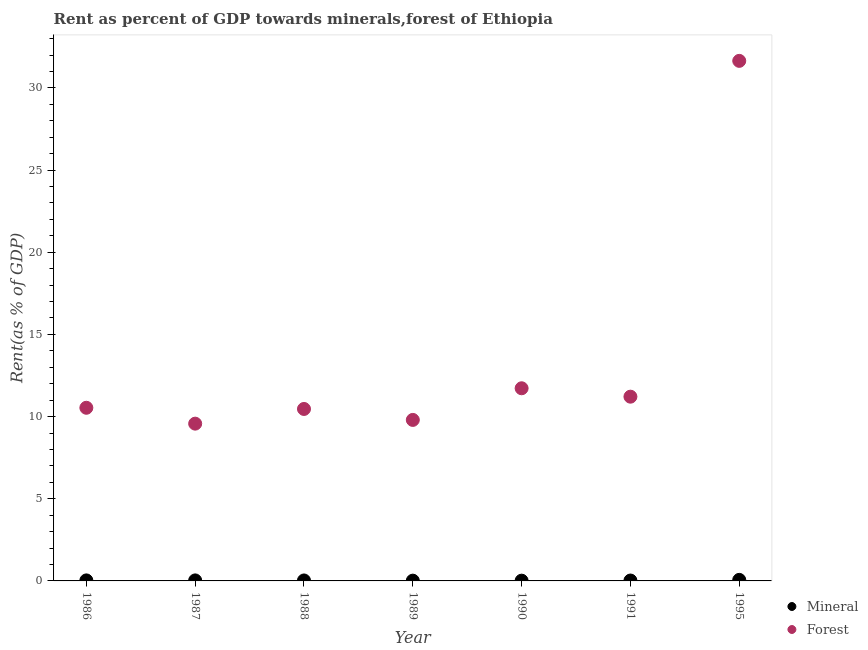How many different coloured dotlines are there?
Make the answer very short. 2. What is the mineral rent in 1987?
Ensure brevity in your answer.  0.03. Across all years, what is the maximum mineral rent?
Provide a short and direct response. 0.06. Across all years, what is the minimum forest rent?
Ensure brevity in your answer.  9.57. In which year was the mineral rent maximum?
Your answer should be compact. 1995. In which year was the forest rent minimum?
Provide a succinct answer. 1987. What is the total forest rent in the graph?
Ensure brevity in your answer.  94.94. What is the difference between the mineral rent in 1987 and that in 1991?
Provide a succinct answer. 0.01. What is the difference between the forest rent in 1990 and the mineral rent in 1995?
Provide a short and direct response. 11.66. What is the average mineral rent per year?
Your response must be concise. 0.03. In the year 1995, what is the difference between the mineral rent and forest rent?
Ensure brevity in your answer.  -31.58. In how many years, is the forest rent greater than 12 %?
Ensure brevity in your answer.  1. What is the ratio of the forest rent in 1987 to that in 1989?
Provide a short and direct response. 0.98. Is the difference between the mineral rent in 1987 and 1991 greater than the difference between the forest rent in 1987 and 1991?
Make the answer very short. Yes. What is the difference between the highest and the second highest mineral rent?
Provide a succinct answer. 0.03. What is the difference between the highest and the lowest forest rent?
Your response must be concise. 22.07. Is the sum of the mineral rent in 1987 and 1989 greater than the maximum forest rent across all years?
Offer a very short reply. No. Does the mineral rent monotonically increase over the years?
Ensure brevity in your answer.  No. Is the mineral rent strictly greater than the forest rent over the years?
Provide a short and direct response. No. How many dotlines are there?
Make the answer very short. 2. How many years are there in the graph?
Make the answer very short. 7. Are the values on the major ticks of Y-axis written in scientific E-notation?
Your answer should be compact. No. How are the legend labels stacked?
Offer a terse response. Vertical. What is the title of the graph?
Keep it short and to the point. Rent as percent of GDP towards minerals,forest of Ethiopia. What is the label or title of the X-axis?
Give a very brief answer. Year. What is the label or title of the Y-axis?
Keep it short and to the point. Rent(as % of GDP). What is the Rent(as % of GDP) of Mineral in 1986?
Provide a succinct answer. 0.03. What is the Rent(as % of GDP) of Forest in 1986?
Your response must be concise. 10.54. What is the Rent(as % of GDP) of Mineral in 1987?
Offer a very short reply. 0.03. What is the Rent(as % of GDP) in Forest in 1987?
Provide a short and direct response. 9.57. What is the Rent(as % of GDP) of Mineral in 1988?
Make the answer very short. 0.03. What is the Rent(as % of GDP) of Forest in 1988?
Your answer should be compact. 10.46. What is the Rent(as % of GDP) of Mineral in 1989?
Give a very brief answer. 0.02. What is the Rent(as % of GDP) in Forest in 1989?
Your answer should be very brief. 9.8. What is the Rent(as % of GDP) in Mineral in 1990?
Your response must be concise. 0.02. What is the Rent(as % of GDP) in Forest in 1990?
Make the answer very short. 11.72. What is the Rent(as % of GDP) of Mineral in 1991?
Offer a terse response. 0.02. What is the Rent(as % of GDP) of Forest in 1991?
Make the answer very short. 11.21. What is the Rent(as % of GDP) of Mineral in 1995?
Provide a short and direct response. 0.06. What is the Rent(as % of GDP) in Forest in 1995?
Provide a short and direct response. 31.64. Across all years, what is the maximum Rent(as % of GDP) of Mineral?
Keep it short and to the point. 0.06. Across all years, what is the maximum Rent(as % of GDP) of Forest?
Keep it short and to the point. 31.64. Across all years, what is the minimum Rent(as % of GDP) of Mineral?
Your answer should be very brief. 0.02. Across all years, what is the minimum Rent(as % of GDP) in Forest?
Keep it short and to the point. 9.57. What is the total Rent(as % of GDP) in Mineral in the graph?
Offer a terse response. 0.21. What is the total Rent(as % of GDP) in Forest in the graph?
Your answer should be compact. 94.94. What is the difference between the Rent(as % of GDP) of Mineral in 1986 and that in 1987?
Provide a short and direct response. 0. What is the difference between the Rent(as % of GDP) of Forest in 1986 and that in 1987?
Make the answer very short. 0.97. What is the difference between the Rent(as % of GDP) of Mineral in 1986 and that in 1988?
Provide a short and direct response. 0. What is the difference between the Rent(as % of GDP) in Forest in 1986 and that in 1988?
Offer a terse response. 0.07. What is the difference between the Rent(as % of GDP) of Mineral in 1986 and that in 1989?
Make the answer very short. 0.02. What is the difference between the Rent(as % of GDP) in Forest in 1986 and that in 1989?
Your answer should be very brief. 0.74. What is the difference between the Rent(as % of GDP) of Mineral in 1986 and that in 1990?
Your answer should be very brief. 0.02. What is the difference between the Rent(as % of GDP) of Forest in 1986 and that in 1990?
Your answer should be compact. -1.19. What is the difference between the Rent(as % of GDP) of Mineral in 1986 and that in 1991?
Ensure brevity in your answer.  0.01. What is the difference between the Rent(as % of GDP) of Forest in 1986 and that in 1991?
Provide a succinct answer. -0.68. What is the difference between the Rent(as % of GDP) of Mineral in 1986 and that in 1995?
Keep it short and to the point. -0.03. What is the difference between the Rent(as % of GDP) in Forest in 1986 and that in 1995?
Your answer should be compact. -21.11. What is the difference between the Rent(as % of GDP) in Mineral in 1987 and that in 1988?
Provide a short and direct response. 0. What is the difference between the Rent(as % of GDP) in Forest in 1987 and that in 1988?
Give a very brief answer. -0.89. What is the difference between the Rent(as % of GDP) of Mineral in 1987 and that in 1989?
Offer a terse response. 0.02. What is the difference between the Rent(as % of GDP) of Forest in 1987 and that in 1989?
Give a very brief answer. -0.23. What is the difference between the Rent(as % of GDP) of Mineral in 1987 and that in 1990?
Make the answer very short. 0.02. What is the difference between the Rent(as % of GDP) of Forest in 1987 and that in 1990?
Provide a succinct answer. -2.15. What is the difference between the Rent(as % of GDP) of Mineral in 1987 and that in 1991?
Make the answer very short. 0.01. What is the difference between the Rent(as % of GDP) in Forest in 1987 and that in 1991?
Your response must be concise. -1.64. What is the difference between the Rent(as % of GDP) of Mineral in 1987 and that in 1995?
Provide a succinct answer. -0.03. What is the difference between the Rent(as % of GDP) in Forest in 1987 and that in 1995?
Offer a very short reply. -22.07. What is the difference between the Rent(as % of GDP) of Mineral in 1988 and that in 1989?
Your answer should be very brief. 0.01. What is the difference between the Rent(as % of GDP) in Mineral in 1988 and that in 1990?
Keep it short and to the point. 0.01. What is the difference between the Rent(as % of GDP) in Forest in 1988 and that in 1990?
Provide a short and direct response. -1.26. What is the difference between the Rent(as % of GDP) in Mineral in 1988 and that in 1991?
Offer a terse response. 0. What is the difference between the Rent(as % of GDP) in Forest in 1988 and that in 1991?
Offer a very short reply. -0.75. What is the difference between the Rent(as % of GDP) of Mineral in 1988 and that in 1995?
Your answer should be very brief. -0.04. What is the difference between the Rent(as % of GDP) in Forest in 1988 and that in 1995?
Provide a short and direct response. -21.18. What is the difference between the Rent(as % of GDP) of Mineral in 1989 and that in 1990?
Your answer should be compact. 0. What is the difference between the Rent(as % of GDP) of Forest in 1989 and that in 1990?
Keep it short and to the point. -1.93. What is the difference between the Rent(as % of GDP) in Mineral in 1989 and that in 1991?
Your response must be concise. -0.01. What is the difference between the Rent(as % of GDP) in Forest in 1989 and that in 1991?
Give a very brief answer. -1.41. What is the difference between the Rent(as % of GDP) in Mineral in 1989 and that in 1995?
Offer a terse response. -0.05. What is the difference between the Rent(as % of GDP) of Forest in 1989 and that in 1995?
Your answer should be very brief. -21.85. What is the difference between the Rent(as % of GDP) in Mineral in 1990 and that in 1991?
Provide a succinct answer. -0.01. What is the difference between the Rent(as % of GDP) in Forest in 1990 and that in 1991?
Offer a very short reply. 0.51. What is the difference between the Rent(as % of GDP) in Mineral in 1990 and that in 1995?
Make the answer very short. -0.05. What is the difference between the Rent(as % of GDP) in Forest in 1990 and that in 1995?
Provide a short and direct response. -19.92. What is the difference between the Rent(as % of GDP) in Mineral in 1991 and that in 1995?
Your response must be concise. -0.04. What is the difference between the Rent(as % of GDP) in Forest in 1991 and that in 1995?
Your answer should be very brief. -20.43. What is the difference between the Rent(as % of GDP) in Mineral in 1986 and the Rent(as % of GDP) in Forest in 1987?
Offer a very short reply. -9.54. What is the difference between the Rent(as % of GDP) of Mineral in 1986 and the Rent(as % of GDP) of Forest in 1988?
Make the answer very short. -10.43. What is the difference between the Rent(as % of GDP) in Mineral in 1986 and the Rent(as % of GDP) in Forest in 1989?
Your answer should be compact. -9.76. What is the difference between the Rent(as % of GDP) in Mineral in 1986 and the Rent(as % of GDP) in Forest in 1990?
Your response must be concise. -11.69. What is the difference between the Rent(as % of GDP) of Mineral in 1986 and the Rent(as % of GDP) of Forest in 1991?
Keep it short and to the point. -11.18. What is the difference between the Rent(as % of GDP) in Mineral in 1986 and the Rent(as % of GDP) in Forest in 1995?
Provide a succinct answer. -31.61. What is the difference between the Rent(as % of GDP) of Mineral in 1987 and the Rent(as % of GDP) of Forest in 1988?
Offer a very short reply. -10.43. What is the difference between the Rent(as % of GDP) in Mineral in 1987 and the Rent(as % of GDP) in Forest in 1989?
Your answer should be compact. -9.77. What is the difference between the Rent(as % of GDP) of Mineral in 1987 and the Rent(as % of GDP) of Forest in 1990?
Provide a succinct answer. -11.69. What is the difference between the Rent(as % of GDP) of Mineral in 1987 and the Rent(as % of GDP) of Forest in 1991?
Ensure brevity in your answer.  -11.18. What is the difference between the Rent(as % of GDP) in Mineral in 1987 and the Rent(as % of GDP) in Forest in 1995?
Give a very brief answer. -31.61. What is the difference between the Rent(as % of GDP) of Mineral in 1988 and the Rent(as % of GDP) of Forest in 1989?
Ensure brevity in your answer.  -9.77. What is the difference between the Rent(as % of GDP) in Mineral in 1988 and the Rent(as % of GDP) in Forest in 1990?
Your answer should be compact. -11.69. What is the difference between the Rent(as % of GDP) of Mineral in 1988 and the Rent(as % of GDP) of Forest in 1991?
Make the answer very short. -11.18. What is the difference between the Rent(as % of GDP) of Mineral in 1988 and the Rent(as % of GDP) of Forest in 1995?
Your answer should be compact. -31.62. What is the difference between the Rent(as % of GDP) in Mineral in 1989 and the Rent(as % of GDP) in Forest in 1990?
Make the answer very short. -11.71. What is the difference between the Rent(as % of GDP) of Mineral in 1989 and the Rent(as % of GDP) of Forest in 1991?
Offer a terse response. -11.19. What is the difference between the Rent(as % of GDP) of Mineral in 1989 and the Rent(as % of GDP) of Forest in 1995?
Give a very brief answer. -31.63. What is the difference between the Rent(as % of GDP) in Mineral in 1990 and the Rent(as % of GDP) in Forest in 1991?
Make the answer very short. -11.2. What is the difference between the Rent(as % of GDP) in Mineral in 1990 and the Rent(as % of GDP) in Forest in 1995?
Offer a terse response. -31.63. What is the difference between the Rent(as % of GDP) of Mineral in 1991 and the Rent(as % of GDP) of Forest in 1995?
Provide a succinct answer. -31.62. What is the average Rent(as % of GDP) in Mineral per year?
Offer a very short reply. 0.03. What is the average Rent(as % of GDP) of Forest per year?
Ensure brevity in your answer.  13.56. In the year 1986, what is the difference between the Rent(as % of GDP) of Mineral and Rent(as % of GDP) of Forest?
Your answer should be compact. -10.5. In the year 1987, what is the difference between the Rent(as % of GDP) in Mineral and Rent(as % of GDP) in Forest?
Make the answer very short. -9.54. In the year 1988, what is the difference between the Rent(as % of GDP) of Mineral and Rent(as % of GDP) of Forest?
Offer a very short reply. -10.44. In the year 1989, what is the difference between the Rent(as % of GDP) in Mineral and Rent(as % of GDP) in Forest?
Offer a very short reply. -9.78. In the year 1990, what is the difference between the Rent(as % of GDP) of Mineral and Rent(as % of GDP) of Forest?
Ensure brevity in your answer.  -11.71. In the year 1991, what is the difference between the Rent(as % of GDP) in Mineral and Rent(as % of GDP) in Forest?
Make the answer very short. -11.19. In the year 1995, what is the difference between the Rent(as % of GDP) in Mineral and Rent(as % of GDP) in Forest?
Offer a terse response. -31.58. What is the ratio of the Rent(as % of GDP) of Mineral in 1986 to that in 1987?
Give a very brief answer. 1.02. What is the ratio of the Rent(as % of GDP) of Forest in 1986 to that in 1987?
Provide a succinct answer. 1.1. What is the ratio of the Rent(as % of GDP) of Mineral in 1986 to that in 1988?
Offer a terse response. 1.13. What is the ratio of the Rent(as % of GDP) of Forest in 1986 to that in 1988?
Keep it short and to the point. 1.01. What is the ratio of the Rent(as % of GDP) of Mineral in 1986 to that in 1989?
Make the answer very short. 1.96. What is the ratio of the Rent(as % of GDP) in Forest in 1986 to that in 1989?
Give a very brief answer. 1.08. What is the ratio of the Rent(as % of GDP) in Mineral in 1986 to that in 1990?
Make the answer very short. 2.08. What is the ratio of the Rent(as % of GDP) of Forest in 1986 to that in 1990?
Offer a very short reply. 0.9. What is the ratio of the Rent(as % of GDP) in Mineral in 1986 to that in 1991?
Make the answer very short. 1.34. What is the ratio of the Rent(as % of GDP) in Forest in 1986 to that in 1991?
Your response must be concise. 0.94. What is the ratio of the Rent(as % of GDP) in Mineral in 1986 to that in 1995?
Offer a very short reply. 0.5. What is the ratio of the Rent(as % of GDP) in Forest in 1986 to that in 1995?
Provide a succinct answer. 0.33. What is the ratio of the Rent(as % of GDP) in Mineral in 1987 to that in 1988?
Give a very brief answer. 1.11. What is the ratio of the Rent(as % of GDP) in Forest in 1987 to that in 1988?
Make the answer very short. 0.91. What is the ratio of the Rent(as % of GDP) of Mineral in 1987 to that in 1989?
Your answer should be very brief. 1.93. What is the ratio of the Rent(as % of GDP) of Forest in 1987 to that in 1989?
Your answer should be very brief. 0.98. What is the ratio of the Rent(as % of GDP) in Mineral in 1987 to that in 1990?
Offer a very short reply. 2.05. What is the ratio of the Rent(as % of GDP) of Forest in 1987 to that in 1990?
Provide a short and direct response. 0.82. What is the ratio of the Rent(as % of GDP) of Mineral in 1987 to that in 1991?
Your answer should be very brief. 1.31. What is the ratio of the Rent(as % of GDP) in Forest in 1987 to that in 1991?
Offer a terse response. 0.85. What is the ratio of the Rent(as % of GDP) of Mineral in 1987 to that in 1995?
Provide a succinct answer. 0.49. What is the ratio of the Rent(as % of GDP) of Forest in 1987 to that in 1995?
Your answer should be compact. 0.3. What is the ratio of the Rent(as % of GDP) of Mineral in 1988 to that in 1989?
Keep it short and to the point. 1.74. What is the ratio of the Rent(as % of GDP) of Forest in 1988 to that in 1989?
Offer a very short reply. 1.07. What is the ratio of the Rent(as % of GDP) in Mineral in 1988 to that in 1990?
Keep it short and to the point. 1.84. What is the ratio of the Rent(as % of GDP) in Forest in 1988 to that in 1990?
Offer a terse response. 0.89. What is the ratio of the Rent(as % of GDP) in Mineral in 1988 to that in 1991?
Provide a short and direct response. 1.18. What is the ratio of the Rent(as % of GDP) of Mineral in 1988 to that in 1995?
Make the answer very short. 0.44. What is the ratio of the Rent(as % of GDP) of Forest in 1988 to that in 1995?
Your response must be concise. 0.33. What is the ratio of the Rent(as % of GDP) in Mineral in 1989 to that in 1990?
Provide a succinct answer. 1.06. What is the ratio of the Rent(as % of GDP) in Forest in 1989 to that in 1990?
Offer a terse response. 0.84. What is the ratio of the Rent(as % of GDP) of Mineral in 1989 to that in 1991?
Your response must be concise. 0.68. What is the ratio of the Rent(as % of GDP) of Forest in 1989 to that in 1991?
Ensure brevity in your answer.  0.87. What is the ratio of the Rent(as % of GDP) in Mineral in 1989 to that in 1995?
Make the answer very short. 0.25. What is the ratio of the Rent(as % of GDP) in Forest in 1989 to that in 1995?
Offer a very short reply. 0.31. What is the ratio of the Rent(as % of GDP) in Mineral in 1990 to that in 1991?
Keep it short and to the point. 0.64. What is the ratio of the Rent(as % of GDP) in Forest in 1990 to that in 1991?
Provide a short and direct response. 1.05. What is the ratio of the Rent(as % of GDP) of Mineral in 1990 to that in 1995?
Keep it short and to the point. 0.24. What is the ratio of the Rent(as % of GDP) of Forest in 1990 to that in 1995?
Ensure brevity in your answer.  0.37. What is the ratio of the Rent(as % of GDP) of Mineral in 1991 to that in 1995?
Offer a very short reply. 0.37. What is the ratio of the Rent(as % of GDP) of Forest in 1991 to that in 1995?
Offer a terse response. 0.35. What is the difference between the highest and the second highest Rent(as % of GDP) in Mineral?
Your answer should be compact. 0.03. What is the difference between the highest and the second highest Rent(as % of GDP) in Forest?
Give a very brief answer. 19.92. What is the difference between the highest and the lowest Rent(as % of GDP) in Mineral?
Give a very brief answer. 0.05. What is the difference between the highest and the lowest Rent(as % of GDP) in Forest?
Make the answer very short. 22.07. 